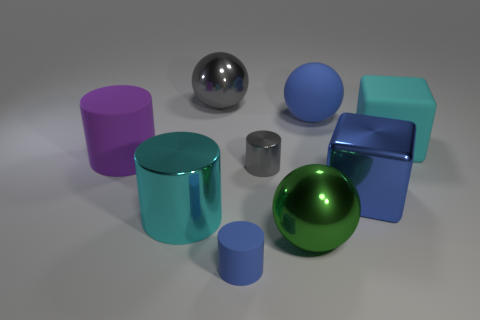What is the size of the gray shiny thing that is the same shape as the cyan metallic thing?
Your response must be concise. Small. Is the material of the big blue thing that is behind the big rubber cylinder the same as the object to the left of the cyan metallic thing?
Offer a terse response. Yes. Is the number of large blue metallic objects that are behind the large purple matte cylinder less than the number of gray shiny cylinders?
Your response must be concise. Yes. The other shiny object that is the same shape as the green metal object is what color?
Make the answer very short. Gray. Do the blue object behind the blue metal cube and the large gray thing have the same size?
Provide a short and direct response. Yes. What size is the blue thing to the left of the tiny cylinder behind the big green sphere?
Provide a short and direct response. Small. Do the big purple cylinder and the cyan thing that is on the right side of the big blue rubber thing have the same material?
Offer a terse response. Yes. Are there fewer gray metallic spheres that are on the left side of the large green metallic thing than big objects that are behind the blue block?
Give a very brief answer. Yes. The large block that is made of the same material as the tiny blue cylinder is what color?
Offer a very short reply. Cyan. Is there a metal thing that is right of the gray metal thing behind the rubber sphere?
Your answer should be compact. Yes. 